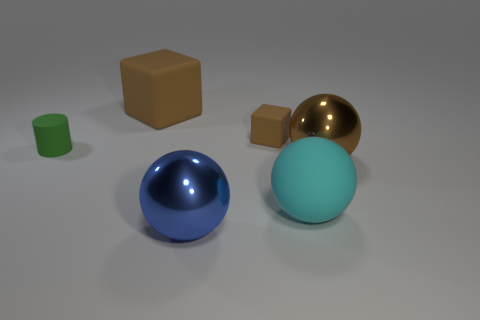There is a tiny matte object to the left of the brown cube behind the small brown cube; is there a big cyan matte thing that is right of it?
Your response must be concise. Yes. There is a large blue object that is the same shape as the big cyan rubber object; what material is it?
Offer a very short reply. Metal. Is there anything else that has the same material as the small brown object?
Your answer should be very brief. Yes. Is the big blue ball made of the same material as the brown object in front of the small green object?
Make the answer very short. Yes. What is the shape of the big object that is behind the metal object behind the large cyan object?
Ensure brevity in your answer.  Cube. What number of big objects are matte balls or green rubber things?
Your answer should be compact. 1. What number of big cyan matte objects are the same shape as the blue metal object?
Offer a terse response. 1. Is the shape of the small green rubber object the same as the large brown object in front of the big brown rubber thing?
Keep it short and to the point. No. What number of large shiny things are right of the large cyan thing?
Your answer should be compact. 1. Is there another green object of the same size as the green object?
Provide a succinct answer. No. 